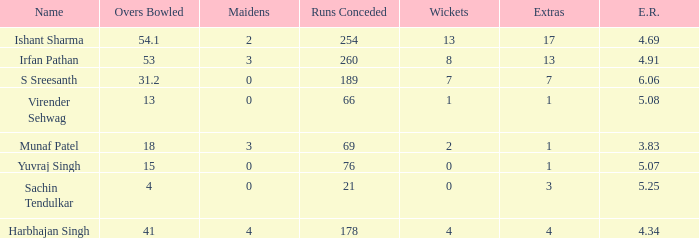Name the total number of wickets being yuvraj singh 1.0. 